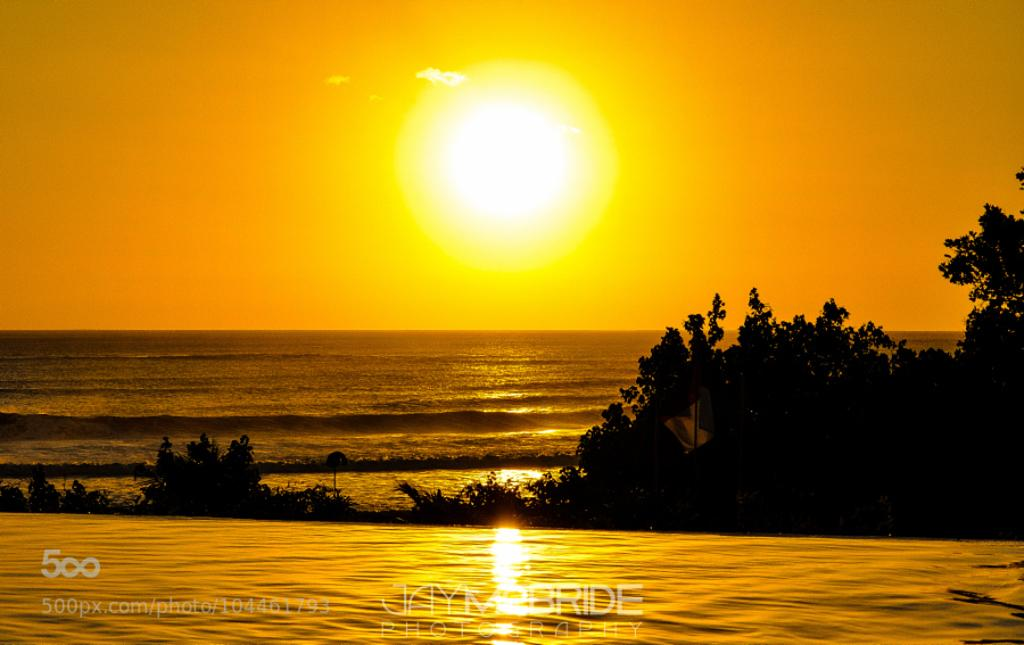What type of natural elements can be seen in the image? There are trees and water visible in the image. What can be seen in the background of the image? The sunlight and sky are visible in the background. Is there any text present in the image? Yes, there is text at the bottom of the image. What type of wire is being used by the self in the image? There is no wire or self present in the image. What is the size of the object in the image? The provided facts do not give information about the size of any object in the image. 